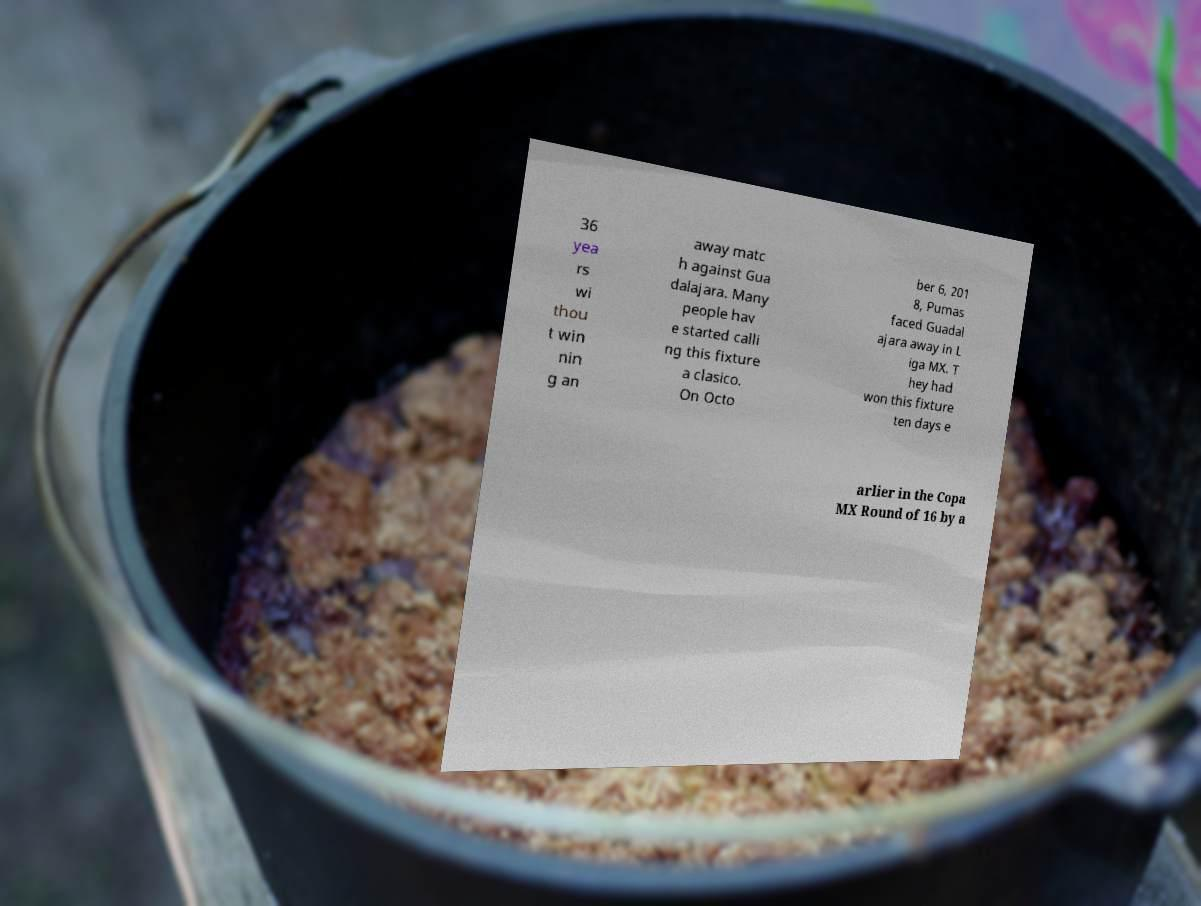For documentation purposes, I need the text within this image transcribed. Could you provide that? 36 yea rs wi thou t win nin g an away matc h against Gua dalajara. Many people hav e started calli ng this fixture a clasico. On Octo ber 6, 201 8, Pumas faced Guadal ajara away in L iga MX. T hey had won this fixture ten days e arlier in the Copa MX Round of 16 by a 